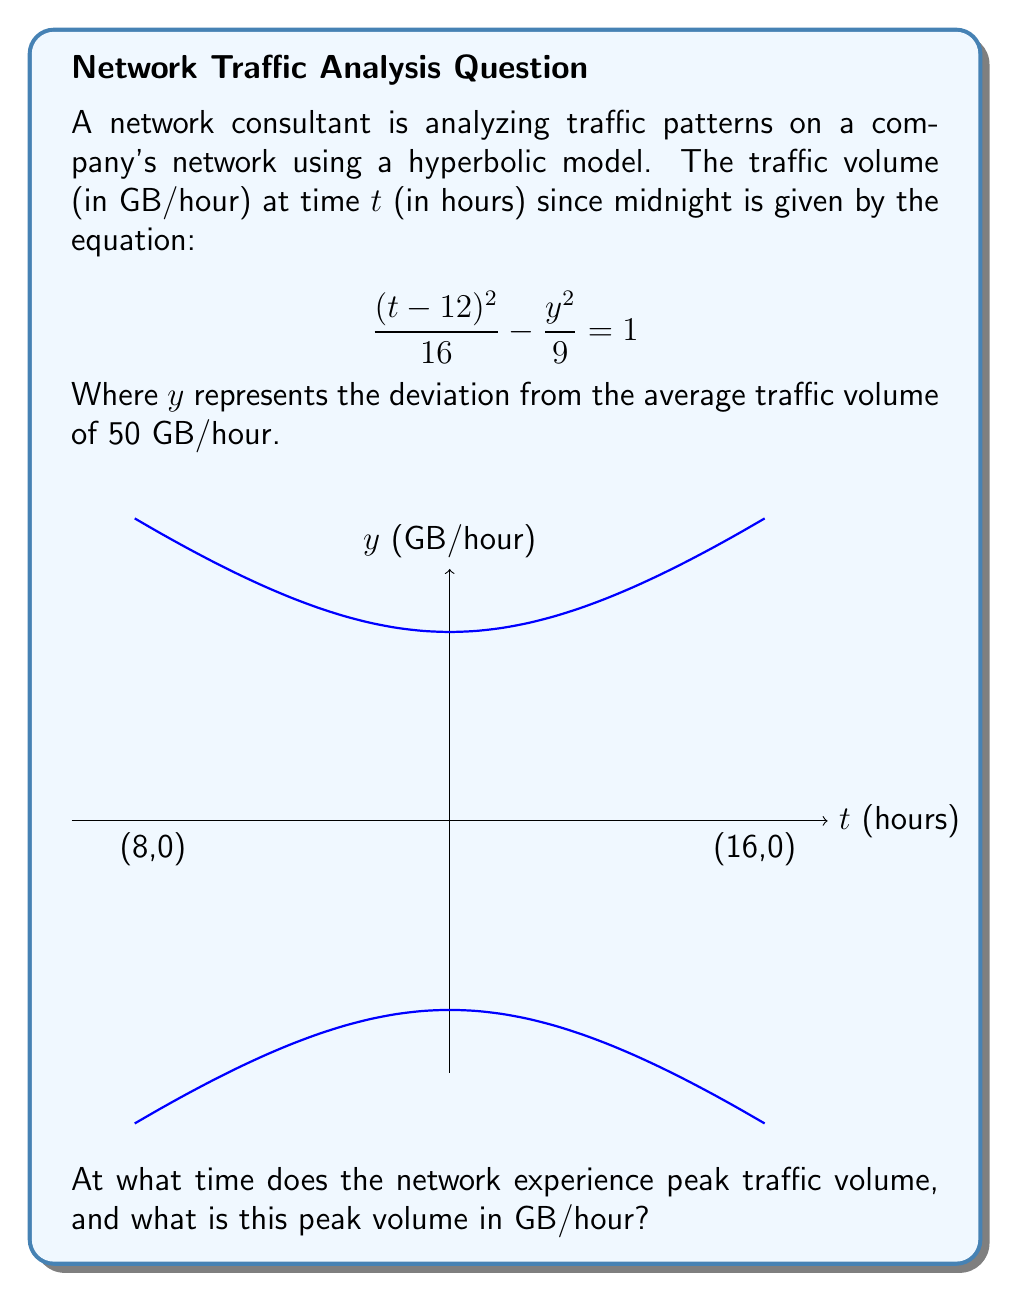Provide a solution to this math problem. Let's approach this step-by-step:

1) The center of the hyperbola is at (12, 0), which represents 12:00 PM (noon).

2) The hyperbola opens horizontally, so the peak traffic will occur at the vertex of the right branch.

3) To find the vertex, we need the distance from the center to the vertex. This is given by the value of 'a' in the standard form of a hyperbola equation:

   $$\frac{x^2}{a^2} - \frac{y^2}{b^2} = 1$$

4) In our equation, $a^2 = 16$ and $b^2 = 9$, so $a = 4$.

5) The x-coordinate of the vertex is therefore 12 + 4 = 16, which represents 4:00 PM.

6) To find the y-coordinate (traffic volume deviation), we can substitute x = 16 into the original equation:

   $$\frac{(16-12)^2}{16} - \frac{y^2}{9} = 1$$
   $$\frac{16}{16} - \frac{y^2}{9} = 1$$
   $$1 - \frac{y^2}{9} = 1$$
   $$-\frac{y^2}{9} = 0$$
   $$y^2 = 0$$
   $$y = 0$$

7) This means there's no deviation from the average traffic at the peak.

8) Recall that the average traffic is 50 GB/hour, so the peak traffic is also 50 GB/hour.
Answer: Peak traffic occurs at 4:00 PM with a volume of 50 GB/hour. 